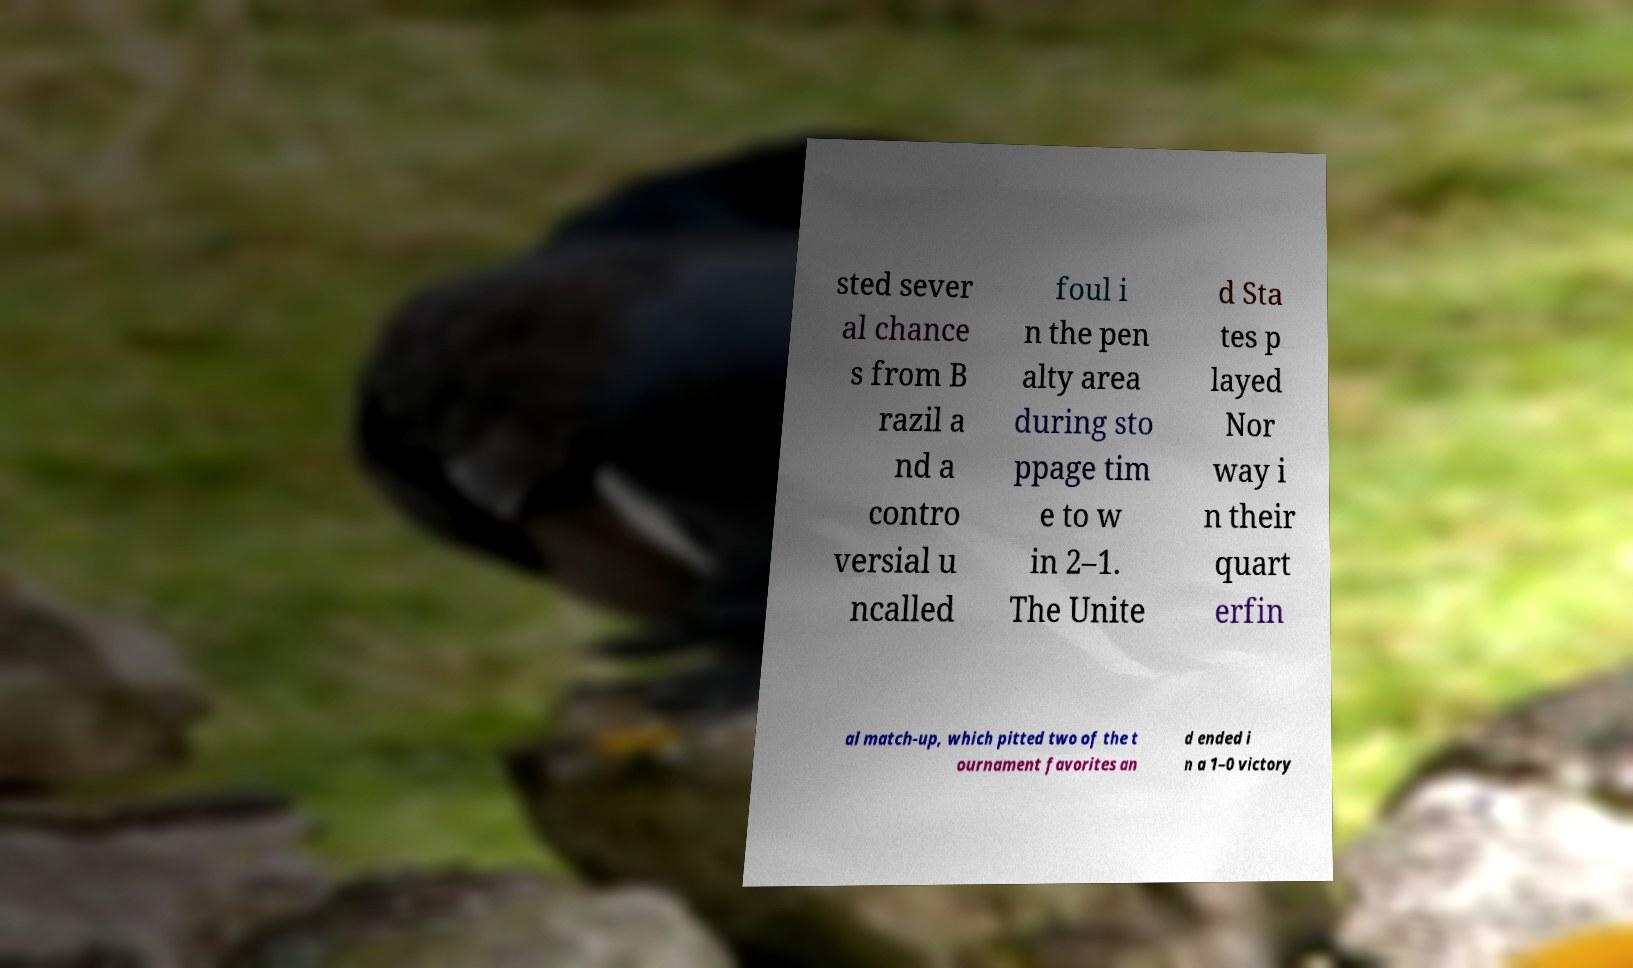Can you accurately transcribe the text from the provided image for me? sted sever al chance s from B razil a nd a contro versial u ncalled foul i n the pen alty area during sto ppage tim e to w in 2–1. The Unite d Sta tes p layed Nor way i n their quart erfin al match-up, which pitted two of the t ournament favorites an d ended i n a 1–0 victory 